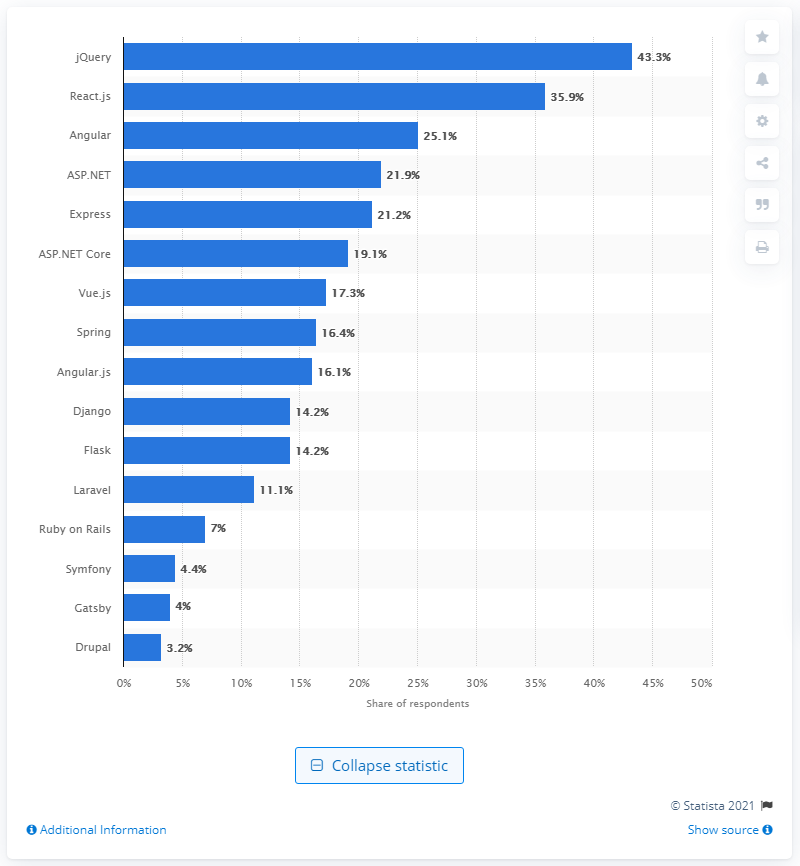Which technologies have a share very close to each other? ASP.NET and Express have shares very close to each other, with ASP.NET at 21.9% and Express at 21.2%. 